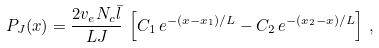Convert formula to latex. <formula><loc_0><loc_0><loc_500><loc_500>P _ { J } ( x ) = \frac { 2 v _ { e } N _ { c } \bar { l } } { L J } \, \left [ C _ { 1 } \, e ^ { - ( x - x _ { 1 } ) / L } - C _ { 2 } \, e ^ { - ( x _ { 2 } - x ) / L } \right ] \, ,</formula> 